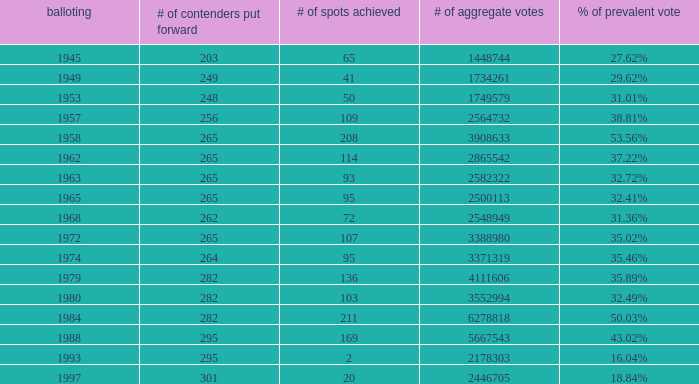What is the election year when the # of candidates nominated was 262? 1.0. 